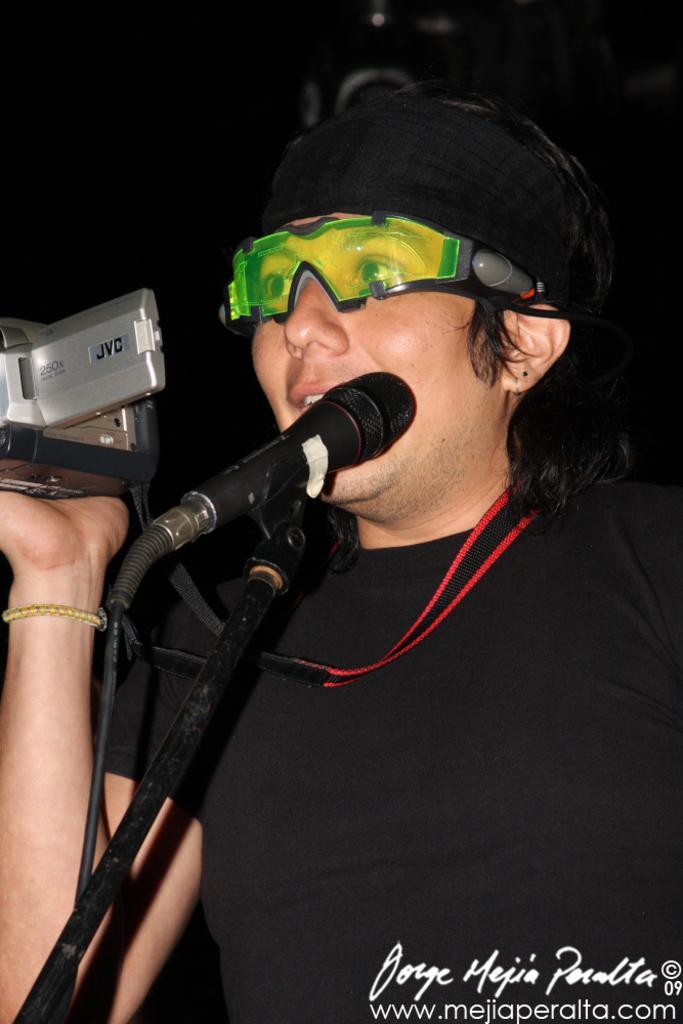Can you describe this image briefly? In this I can see a person is holding a camera in right hand. This person wore a black color t-shirt, cap, there is a microphone in black color. At the bottom there is the watermark name. 